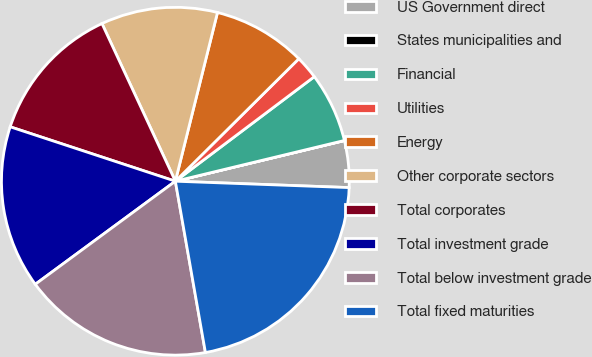Convert chart to OTSL. <chart><loc_0><loc_0><loc_500><loc_500><pie_chart><fcel>US Government direct<fcel>States municipalities and<fcel>Financial<fcel>Utilities<fcel>Energy<fcel>Other corporate sectors<fcel>Total corporates<fcel>Total investment grade<fcel>Total below investment grade<fcel>Total fixed maturities<nl><fcel>4.34%<fcel>0.01%<fcel>6.5%<fcel>2.17%<fcel>8.67%<fcel>10.83%<fcel>13.0%<fcel>15.16%<fcel>17.67%<fcel>21.65%<nl></chart> 